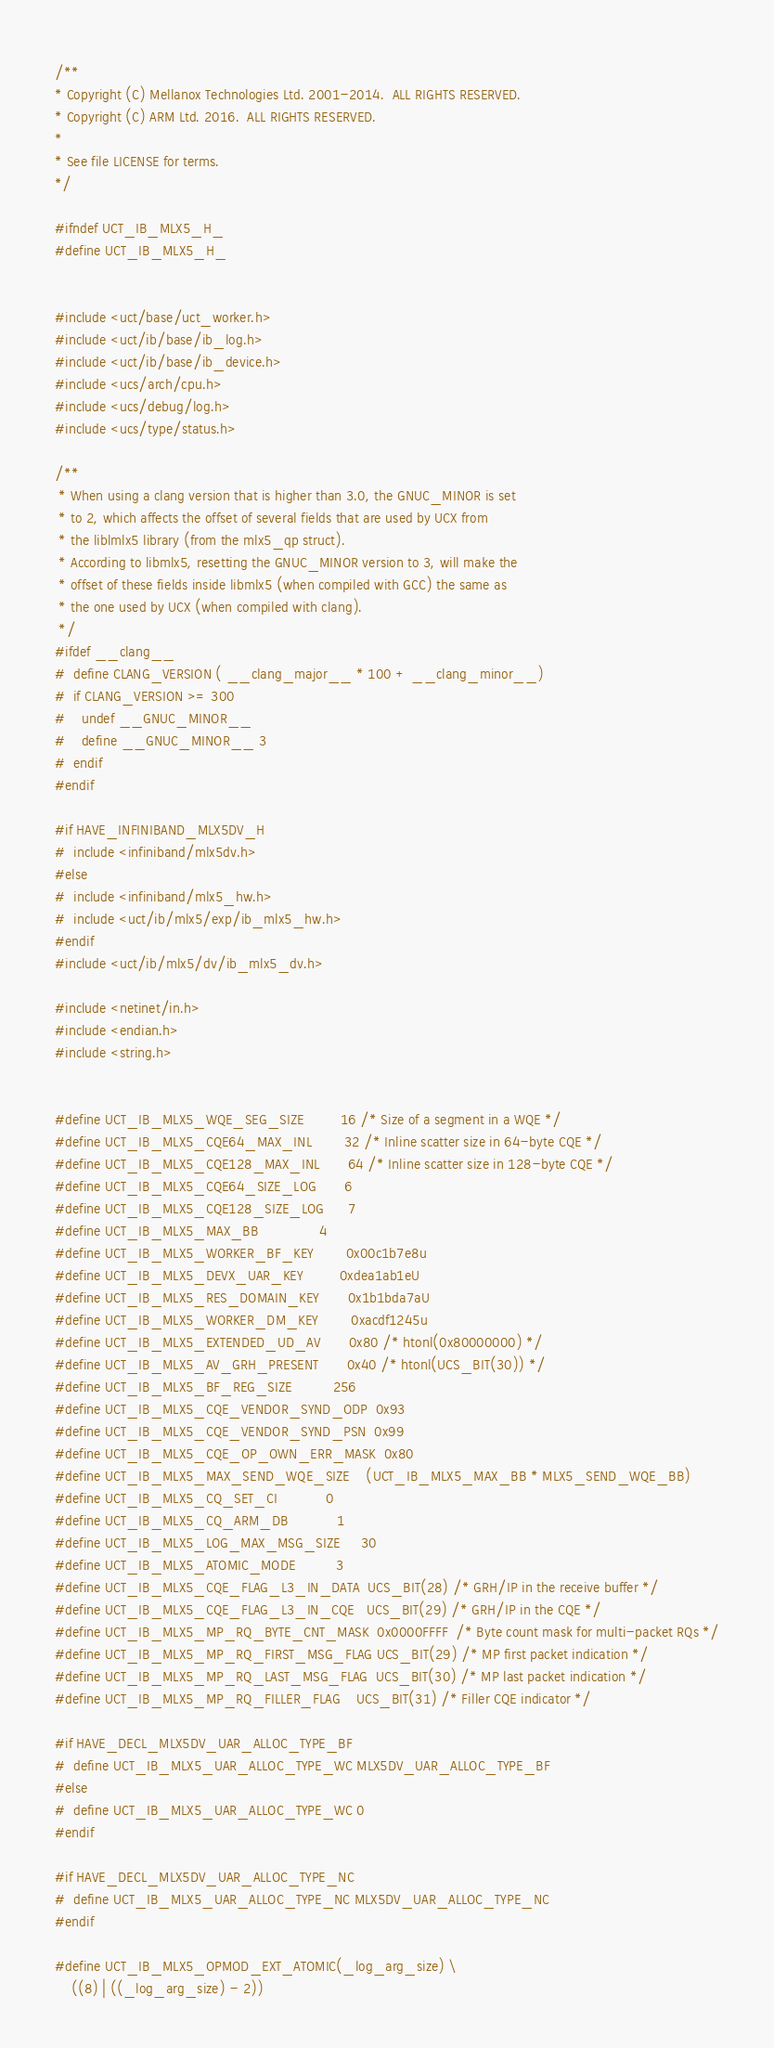Convert code to text. <code><loc_0><loc_0><loc_500><loc_500><_C_>/**
* Copyright (C) Mellanox Technologies Ltd. 2001-2014.  ALL RIGHTS RESERVED.
* Copyright (C) ARM Ltd. 2016.  ALL RIGHTS RESERVED.
*
* See file LICENSE for terms.
*/

#ifndef UCT_IB_MLX5_H_
#define UCT_IB_MLX5_H_


#include <uct/base/uct_worker.h>
#include <uct/ib/base/ib_log.h>
#include <uct/ib/base/ib_device.h>
#include <ucs/arch/cpu.h>
#include <ucs/debug/log.h>
#include <ucs/type/status.h>

/**
 * When using a clang version that is higher than 3.0, the GNUC_MINOR is set
 * to 2, which affects the offset of several fields that are used by UCX from
 * the liblmlx5 library (from the mlx5_qp struct).
 * According to libmlx5, resetting the GNUC_MINOR version to 3, will make the
 * offset of these fields inside libmlx5 (when compiled with GCC) the same as
 * the one used by UCX (when compiled with clang).
 */
#ifdef __clang__
#  define CLANG_VERSION ( __clang_major__ * 100 + __clang_minor__)
#  if CLANG_VERSION >= 300
#    undef __GNUC_MINOR__
#    define __GNUC_MINOR__ 3
#  endif
#endif

#if HAVE_INFINIBAND_MLX5DV_H
#  include <infiniband/mlx5dv.h>
#else
#  include <infiniband/mlx5_hw.h>
#  include <uct/ib/mlx5/exp/ib_mlx5_hw.h>
#endif
#include <uct/ib/mlx5/dv/ib_mlx5_dv.h>

#include <netinet/in.h>
#include <endian.h>
#include <string.h>


#define UCT_IB_MLX5_WQE_SEG_SIZE         16 /* Size of a segment in a WQE */
#define UCT_IB_MLX5_CQE64_MAX_INL        32 /* Inline scatter size in 64-byte CQE */
#define UCT_IB_MLX5_CQE128_MAX_INL       64 /* Inline scatter size in 128-byte CQE */
#define UCT_IB_MLX5_CQE64_SIZE_LOG       6
#define UCT_IB_MLX5_CQE128_SIZE_LOG      7
#define UCT_IB_MLX5_MAX_BB               4
#define UCT_IB_MLX5_WORKER_BF_KEY        0x00c1b7e8u
#define UCT_IB_MLX5_DEVX_UAR_KEY         0xdea1ab1eU
#define UCT_IB_MLX5_RES_DOMAIN_KEY       0x1b1bda7aU
#define UCT_IB_MLX5_WORKER_DM_KEY        0xacdf1245u
#define UCT_IB_MLX5_EXTENDED_UD_AV       0x80 /* htonl(0x80000000) */
#define UCT_IB_MLX5_AV_GRH_PRESENT       0x40 /* htonl(UCS_BIT(30)) */
#define UCT_IB_MLX5_BF_REG_SIZE          256
#define UCT_IB_MLX5_CQE_VENDOR_SYND_ODP  0x93
#define UCT_IB_MLX5_CQE_VENDOR_SYND_PSN  0x99
#define UCT_IB_MLX5_CQE_OP_OWN_ERR_MASK  0x80
#define UCT_IB_MLX5_MAX_SEND_WQE_SIZE    (UCT_IB_MLX5_MAX_BB * MLX5_SEND_WQE_BB)
#define UCT_IB_MLX5_CQ_SET_CI            0
#define UCT_IB_MLX5_CQ_ARM_DB            1
#define UCT_IB_MLX5_LOG_MAX_MSG_SIZE     30
#define UCT_IB_MLX5_ATOMIC_MODE          3
#define UCT_IB_MLX5_CQE_FLAG_L3_IN_DATA  UCS_BIT(28) /* GRH/IP in the receive buffer */
#define UCT_IB_MLX5_CQE_FLAG_L3_IN_CQE   UCS_BIT(29) /* GRH/IP in the CQE */
#define UCT_IB_MLX5_MP_RQ_BYTE_CNT_MASK  0x0000FFFF  /* Byte count mask for multi-packet RQs */
#define UCT_IB_MLX5_MP_RQ_FIRST_MSG_FLAG UCS_BIT(29) /* MP first packet indication */
#define UCT_IB_MLX5_MP_RQ_LAST_MSG_FLAG  UCS_BIT(30) /* MP last packet indication */
#define UCT_IB_MLX5_MP_RQ_FILLER_FLAG    UCS_BIT(31) /* Filler CQE indicator */

#if HAVE_DECL_MLX5DV_UAR_ALLOC_TYPE_BF
#  define UCT_IB_MLX5_UAR_ALLOC_TYPE_WC MLX5DV_UAR_ALLOC_TYPE_BF
#else
#  define UCT_IB_MLX5_UAR_ALLOC_TYPE_WC 0
#endif

#if HAVE_DECL_MLX5DV_UAR_ALLOC_TYPE_NC
#  define UCT_IB_MLX5_UAR_ALLOC_TYPE_NC MLX5DV_UAR_ALLOC_TYPE_NC
#endif

#define UCT_IB_MLX5_OPMOD_EXT_ATOMIC(_log_arg_size) \
    ((8) | ((_log_arg_size) - 2))
</code> 